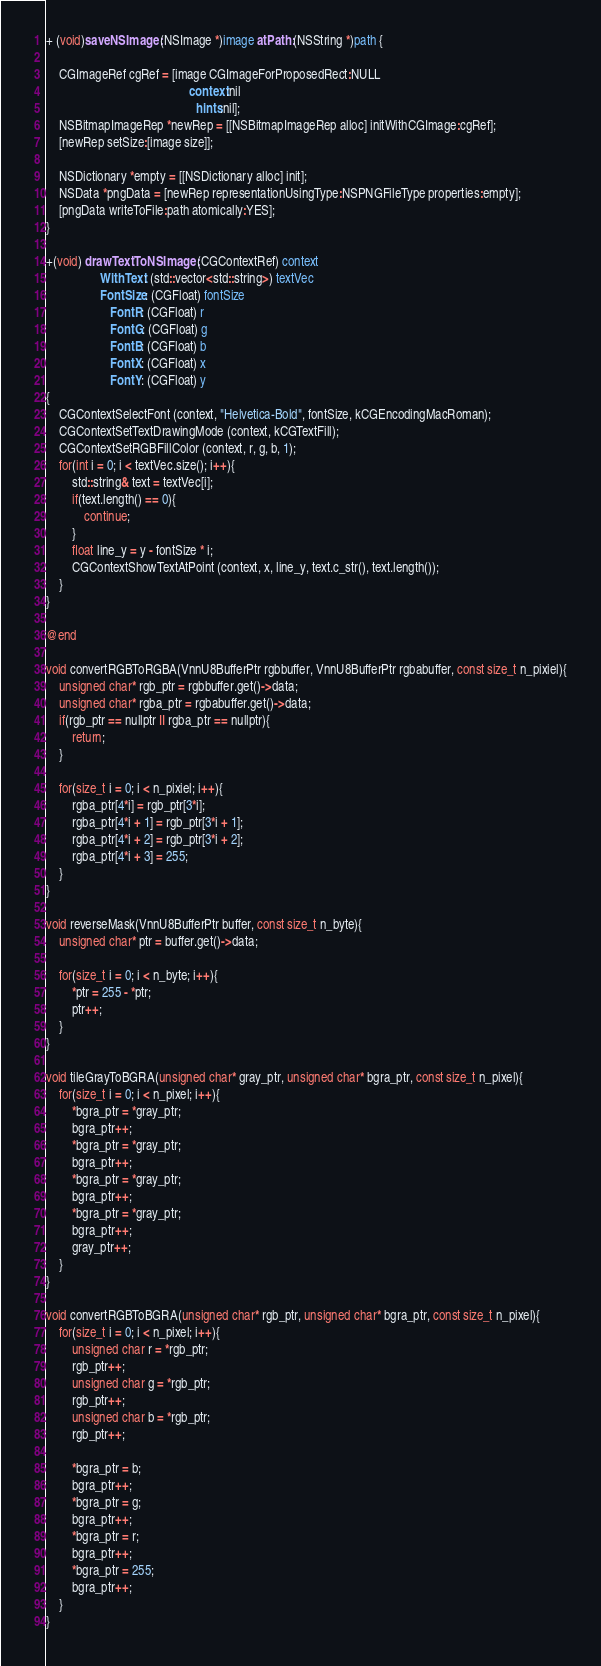<code> <loc_0><loc_0><loc_500><loc_500><_ObjectiveC_>+ (void)saveNSImage:(NSImage *)image atPath:(NSString *)path {
    
    CGImageRef cgRef = [image CGImageForProposedRect:NULL
                                             context:nil
                                               hints:nil];
    NSBitmapImageRep *newRep = [[NSBitmapImageRep alloc] initWithCGImage:cgRef];
    [newRep setSize:[image size]];
    
    NSDictionary *empty = [[NSDictionary alloc] init];
    NSData *pngData = [newRep representationUsingType:NSPNGFileType properties:empty];
    [pngData writeToFile:path atomically:YES];
}

+(void) drawTextToNSImage: (CGContextRef) context
                 WithText: (std::vector<std::string>) textVec
                 FontSize: (CGFloat) fontSize
                    FontR: (CGFloat) r
                    FontG: (CGFloat) g
                    FontB: (CGFloat) b
                    FontX: (CGFloat) x
                    FontY: (CGFloat) y
{
    CGContextSelectFont (context, "Helvetica-Bold", fontSize, kCGEncodingMacRoman);
    CGContextSetTextDrawingMode (context, kCGTextFill);
    CGContextSetRGBFillColor (context, r, g, b, 1);
    for(int i = 0; i < textVec.size(); i++){
        std::string& text = textVec[i];
        if(text.length() == 0){
            continue;
        }
        float line_y = y - fontSize * i;
        CGContextShowTextAtPoint (context, x, line_y, text.c_str(), text.length());
    }
}

@end

void convertRGBToRGBA(VnnU8BufferPtr rgbbuffer, VnnU8BufferPtr rgbabuffer, const size_t n_pixiel){
    unsigned char* rgb_ptr = rgbbuffer.get()->data;
    unsigned char* rgba_ptr = rgbabuffer.get()->data;
    if(rgb_ptr == nullptr || rgba_ptr == nullptr){
        return;
    }

    for(size_t i = 0; i < n_pixiel; i++){
        rgba_ptr[4*i] = rgb_ptr[3*i];
        rgba_ptr[4*i + 1] = rgb_ptr[3*i + 1];
        rgba_ptr[4*i + 2] = rgb_ptr[3*i + 2];
        rgba_ptr[4*i + 3] = 255;
    }
}

void reverseMask(VnnU8BufferPtr buffer, const size_t n_byte){
    unsigned char* ptr = buffer.get()->data;

    for(size_t i = 0; i < n_byte; i++){
        *ptr = 255 - *ptr;
        ptr++;
    }
}

void tileGrayToBGRA(unsigned char* gray_ptr, unsigned char* bgra_ptr, const size_t n_pixel){
    for(size_t i = 0; i < n_pixel; i++){
        *bgra_ptr = *gray_ptr;
        bgra_ptr++;
        *bgra_ptr = *gray_ptr;
        bgra_ptr++;
        *bgra_ptr = *gray_ptr;
        bgra_ptr++;
        *bgra_ptr = *gray_ptr;
        bgra_ptr++;
        gray_ptr++;
    }
}

void convertRGBToBGRA(unsigned char* rgb_ptr, unsigned char* bgra_ptr, const size_t n_pixel){
    for(size_t i = 0; i < n_pixel; i++){
        unsigned char r = *rgb_ptr;
        rgb_ptr++;
        unsigned char g = *rgb_ptr;
        rgb_ptr++;
        unsigned char b = *rgb_ptr;
        rgb_ptr++;
        
        *bgra_ptr = b;
        bgra_ptr++;
        *bgra_ptr = g;
        bgra_ptr++;
        *bgra_ptr = r;
        bgra_ptr++;
        *bgra_ptr = 255;
        bgra_ptr++;
    }
}
</code> 